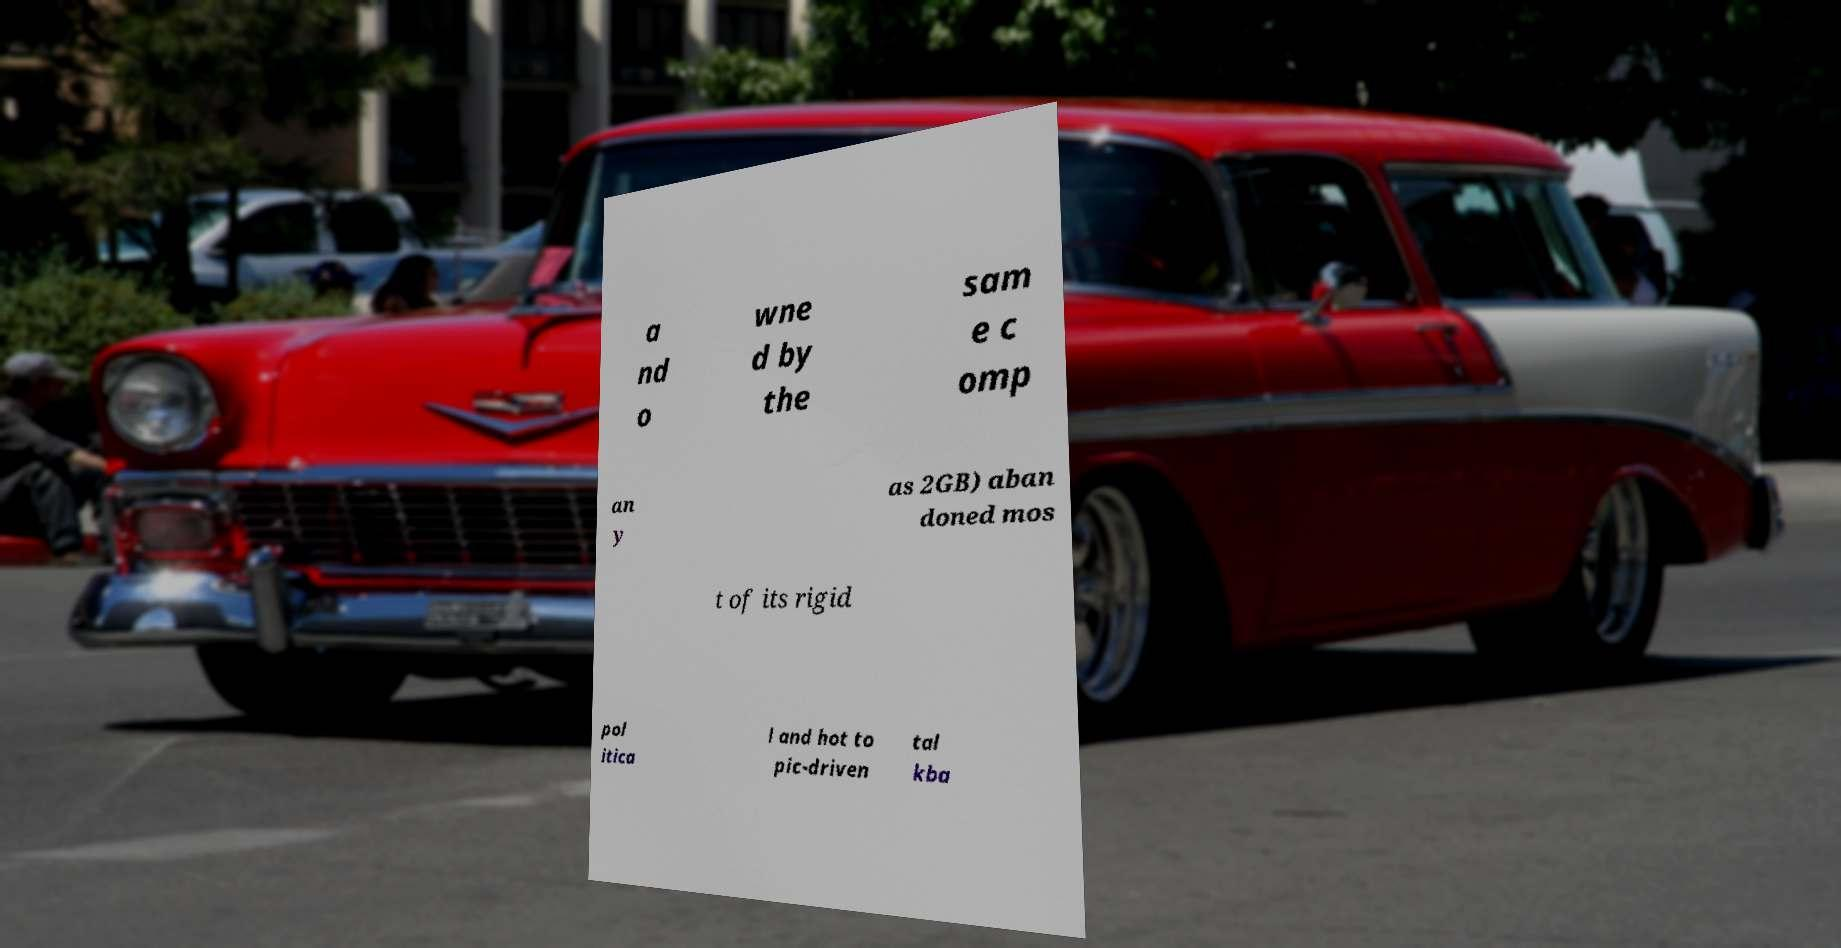I need the written content from this picture converted into text. Can you do that? a nd o wne d by the sam e c omp an y as 2GB) aban doned mos t of its rigid pol itica l and hot to pic-driven tal kba 